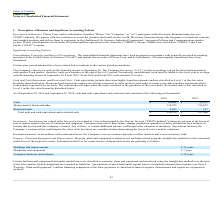From Plexus's financial document, Which years does the table provide information for cash and cash equivalents and restricted cash? The document shows two values: 2019 and 2018. From the document: "2019 2018 2019 2018..." Also, What was the amount of Cash in 2018? According to the financial document, 99,197 (in thousands). The relevant text states: "Cash $ 85,688 $ 99,197..." Also, What was the amount of Restricted Cash in 2019? According to the financial document, 2,493 (in thousands). The relevant text states: "Restricted cash 2,493 417..." Also, How many years did the Money market funds and other exceed $100,000 thousand? Counting the relevant items in the document: 2019, 2018, I find 2 instances. The key data points involved are: 2018, 2019. Also, can you calculate: What was the change in the Restricted cash between 2018 and 2019? Based on the calculation: 2,493-417, the result is 2076. This is based on the information: "Restricted cash 2,493 417 Restricted cash 2,493 417..." The key data points involved are: 2,493, 417. Also, can you calculate: What was the percentage change in the Total cash and cash equivalents and restricted cash between 2018 and 2019? To answer this question, I need to perform calculations using the financial data. The calculation is: (226,254-297,686)/297,686, which equals -24 (percentage). This is based on the information: "cash equivalents and restricted cash $ 226,254 $ 297,686 l cash and cash equivalents and restricted cash $ 226,254 $ 297,686..." The key data points involved are: 226,254, 297,686. 